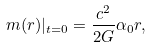Convert formula to latex. <formula><loc_0><loc_0><loc_500><loc_500>m ( r ) | _ { t = 0 } = \frac { c ^ { 2 } } { 2 G } \alpha _ { 0 } r ,</formula> 